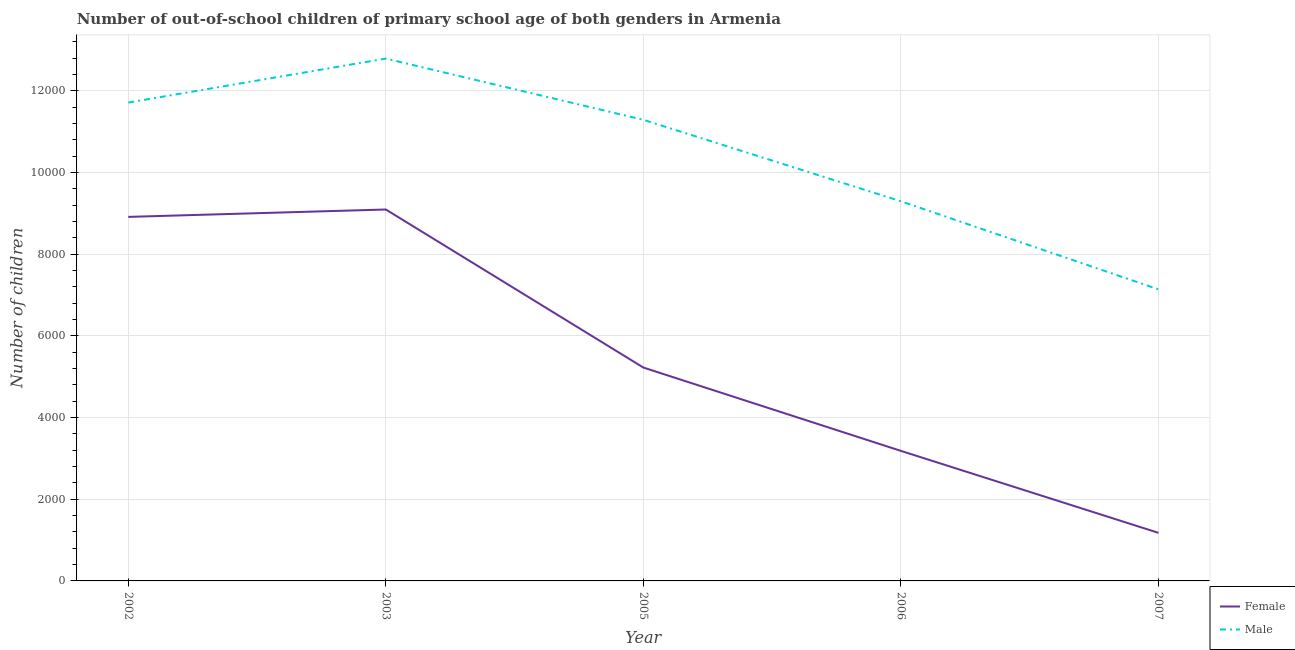What is the number of male out-of-school students in 2002?
Your answer should be very brief. 1.17e+04. Across all years, what is the maximum number of female out-of-school students?
Your answer should be very brief. 9092. Across all years, what is the minimum number of male out-of-school students?
Make the answer very short. 7137. In which year was the number of female out-of-school students maximum?
Offer a terse response. 2003. What is the total number of male out-of-school students in the graph?
Provide a succinct answer. 5.22e+04. What is the difference between the number of female out-of-school students in 2003 and that in 2007?
Offer a terse response. 7915. What is the difference between the number of male out-of-school students in 2002 and the number of female out-of-school students in 2003?
Give a very brief answer. 2618. What is the average number of female out-of-school students per year?
Make the answer very short. 5517.2. In the year 2002, what is the difference between the number of female out-of-school students and number of male out-of-school students?
Provide a short and direct response. -2799. In how many years, is the number of female out-of-school students greater than 6000?
Provide a succinct answer. 2. What is the ratio of the number of male out-of-school students in 2005 to that in 2006?
Your answer should be compact. 1.21. What is the difference between the highest and the second highest number of female out-of-school students?
Offer a terse response. 181. What is the difference between the highest and the lowest number of male out-of-school students?
Provide a short and direct response. 5649. Is the sum of the number of male out-of-school students in 2003 and 2006 greater than the maximum number of female out-of-school students across all years?
Provide a short and direct response. Yes. Does the number of female out-of-school students monotonically increase over the years?
Give a very brief answer. No. Is the number of male out-of-school students strictly less than the number of female out-of-school students over the years?
Your response must be concise. No. How many lines are there?
Offer a very short reply. 2. Are the values on the major ticks of Y-axis written in scientific E-notation?
Your response must be concise. No. How many legend labels are there?
Provide a short and direct response. 2. How are the legend labels stacked?
Your answer should be very brief. Vertical. What is the title of the graph?
Your response must be concise. Number of out-of-school children of primary school age of both genders in Armenia. What is the label or title of the X-axis?
Your answer should be compact. Year. What is the label or title of the Y-axis?
Your answer should be compact. Number of children. What is the Number of children in Female in 2002?
Your answer should be very brief. 8911. What is the Number of children in Male in 2002?
Ensure brevity in your answer.  1.17e+04. What is the Number of children of Female in 2003?
Provide a short and direct response. 9092. What is the Number of children in Male in 2003?
Give a very brief answer. 1.28e+04. What is the Number of children in Female in 2005?
Offer a terse response. 5223. What is the Number of children of Male in 2005?
Ensure brevity in your answer.  1.13e+04. What is the Number of children of Female in 2006?
Provide a short and direct response. 3183. What is the Number of children in Male in 2006?
Make the answer very short. 9293. What is the Number of children in Female in 2007?
Your response must be concise. 1177. What is the Number of children in Male in 2007?
Make the answer very short. 7137. Across all years, what is the maximum Number of children of Female?
Provide a short and direct response. 9092. Across all years, what is the maximum Number of children of Male?
Provide a short and direct response. 1.28e+04. Across all years, what is the minimum Number of children in Female?
Your response must be concise. 1177. Across all years, what is the minimum Number of children in Male?
Give a very brief answer. 7137. What is the total Number of children of Female in the graph?
Offer a very short reply. 2.76e+04. What is the total Number of children of Male in the graph?
Your answer should be very brief. 5.22e+04. What is the difference between the Number of children in Female in 2002 and that in 2003?
Provide a succinct answer. -181. What is the difference between the Number of children in Male in 2002 and that in 2003?
Ensure brevity in your answer.  -1076. What is the difference between the Number of children in Female in 2002 and that in 2005?
Your answer should be very brief. 3688. What is the difference between the Number of children in Male in 2002 and that in 2005?
Make the answer very short. 423. What is the difference between the Number of children in Female in 2002 and that in 2006?
Provide a short and direct response. 5728. What is the difference between the Number of children of Male in 2002 and that in 2006?
Make the answer very short. 2417. What is the difference between the Number of children of Female in 2002 and that in 2007?
Your answer should be compact. 7734. What is the difference between the Number of children of Male in 2002 and that in 2007?
Offer a very short reply. 4573. What is the difference between the Number of children of Female in 2003 and that in 2005?
Provide a short and direct response. 3869. What is the difference between the Number of children of Male in 2003 and that in 2005?
Your answer should be very brief. 1499. What is the difference between the Number of children of Female in 2003 and that in 2006?
Keep it short and to the point. 5909. What is the difference between the Number of children of Male in 2003 and that in 2006?
Give a very brief answer. 3493. What is the difference between the Number of children of Female in 2003 and that in 2007?
Provide a short and direct response. 7915. What is the difference between the Number of children of Male in 2003 and that in 2007?
Your answer should be compact. 5649. What is the difference between the Number of children in Female in 2005 and that in 2006?
Give a very brief answer. 2040. What is the difference between the Number of children in Male in 2005 and that in 2006?
Your answer should be very brief. 1994. What is the difference between the Number of children in Female in 2005 and that in 2007?
Give a very brief answer. 4046. What is the difference between the Number of children of Male in 2005 and that in 2007?
Your answer should be compact. 4150. What is the difference between the Number of children of Female in 2006 and that in 2007?
Offer a very short reply. 2006. What is the difference between the Number of children of Male in 2006 and that in 2007?
Offer a terse response. 2156. What is the difference between the Number of children of Female in 2002 and the Number of children of Male in 2003?
Provide a succinct answer. -3875. What is the difference between the Number of children in Female in 2002 and the Number of children in Male in 2005?
Keep it short and to the point. -2376. What is the difference between the Number of children of Female in 2002 and the Number of children of Male in 2006?
Your response must be concise. -382. What is the difference between the Number of children of Female in 2002 and the Number of children of Male in 2007?
Your response must be concise. 1774. What is the difference between the Number of children in Female in 2003 and the Number of children in Male in 2005?
Provide a short and direct response. -2195. What is the difference between the Number of children of Female in 2003 and the Number of children of Male in 2006?
Give a very brief answer. -201. What is the difference between the Number of children of Female in 2003 and the Number of children of Male in 2007?
Offer a terse response. 1955. What is the difference between the Number of children of Female in 2005 and the Number of children of Male in 2006?
Your answer should be very brief. -4070. What is the difference between the Number of children in Female in 2005 and the Number of children in Male in 2007?
Offer a terse response. -1914. What is the difference between the Number of children of Female in 2006 and the Number of children of Male in 2007?
Keep it short and to the point. -3954. What is the average Number of children of Female per year?
Offer a terse response. 5517.2. What is the average Number of children in Male per year?
Offer a terse response. 1.04e+04. In the year 2002, what is the difference between the Number of children in Female and Number of children in Male?
Ensure brevity in your answer.  -2799. In the year 2003, what is the difference between the Number of children in Female and Number of children in Male?
Provide a short and direct response. -3694. In the year 2005, what is the difference between the Number of children of Female and Number of children of Male?
Keep it short and to the point. -6064. In the year 2006, what is the difference between the Number of children in Female and Number of children in Male?
Your answer should be compact. -6110. In the year 2007, what is the difference between the Number of children of Female and Number of children of Male?
Provide a succinct answer. -5960. What is the ratio of the Number of children in Female in 2002 to that in 2003?
Provide a short and direct response. 0.98. What is the ratio of the Number of children of Male in 2002 to that in 2003?
Your response must be concise. 0.92. What is the ratio of the Number of children of Female in 2002 to that in 2005?
Your response must be concise. 1.71. What is the ratio of the Number of children in Male in 2002 to that in 2005?
Provide a succinct answer. 1.04. What is the ratio of the Number of children of Female in 2002 to that in 2006?
Give a very brief answer. 2.8. What is the ratio of the Number of children of Male in 2002 to that in 2006?
Your answer should be very brief. 1.26. What is the ratio of the Number of children of Female in 2002 to that in 2007?
Offer a terse response. 7.57. What is the ratio of the Number of children of Male in 2002 to that in 2007?
Make the answer very short. 1.64. What is the ratio of the Number of children of Female in 2003 to that in 2005?
Your response must be concise. 1.74. What is the ratio of the Number of children in Male in 2003 to that in 2005?
Provide a succinct answer. 1.13. What is the ratio of the Number of children in Female in 2003 to that in 2006?
Your answer should be compact. 2.86. What is the ratio of the Number of children of Male in 2003 to that in 2006?
Your answer should be very brief. 1.38. What is the ratio of the Number of children in Female in 2003 to that in 2007?
Provide a succinct answer. 7.72. What is the ratio of the Number of children in Male in 2003 to that in 2007?
Give a very brief answer. 1.79. What is the ratio of the Number of children of Female in 2005 to that in 2006?
Make the answer very short. 1.64. What is the ratio of the Number of children in Male in 2005 to that in 2006?
Give a very brief answer. 1.21. What is the ratio of the Number of children in Female in 2005 to that in 2007?
Provide a succinct answer. 4.44. What is the ratio of the Number of children in Male in 2005 to that in 2007?
Offer a terse response. 1.58. What is the ratio of the Number of children of Female in 2006 to that in 2007?
Offer a very short reply. 2.7. What is the ratio of the Number of children of Male in 2006 to that in 2007?
Give a very brief answer. 1.3. What is the difference between the highest and the second highest Number of children of Female?
Your answer should be compact. 181. What is the difference between the highest and the second highest Number of children of Male?
Make the answer very short. 1076. What is the difference between the highest and the lowest Number of children in Female?
Keep it short and to the point. 7915. What is the difference between the highest and the lowest Number of children of Male?
Provide a short and direct response. 5649. 